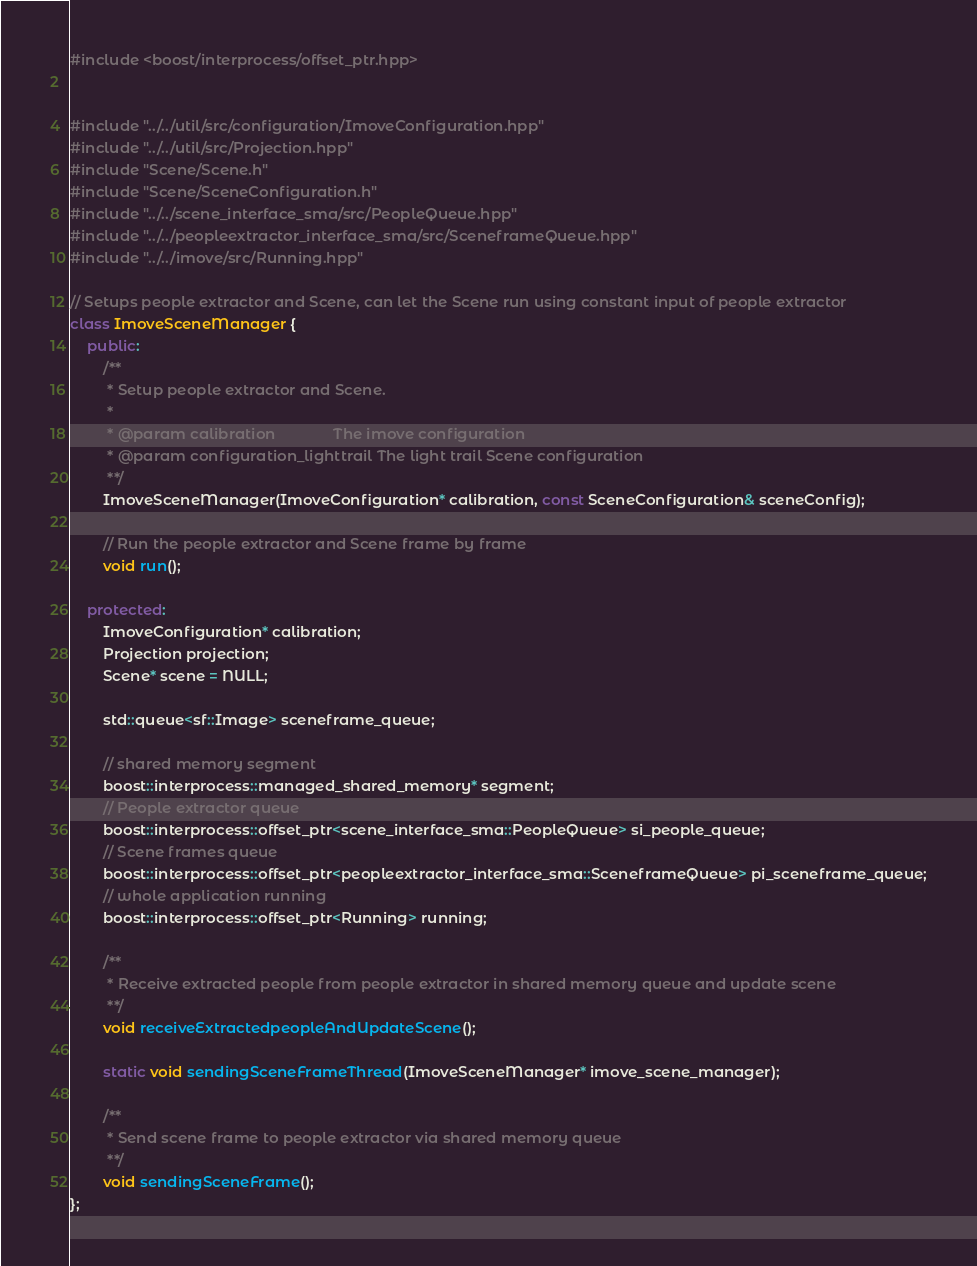Convert code to text. <code><loc_0><loc_0><loc_500><loc_500><_C++_>#include <boost/interprocess/offset_ptr.hpp>


#include "../../util/src/configuration/ImoveConfiguration.hpp"
#include "../../util/src/Projection.hpp"
#include "Scene/Scene.h"
#include "Scene/SceneConfiguration.h"
#include "../../scene_interface_sma/src/PeopleQueue.hpp"
#include "../../peopleextractor_interface_sma/src/SceneframeQueue.hpp"
#include "../../imove/src/Running.hpp"

// Setups people extractor and Scene, can let the Scene run using constant input of people extractor
class ImoveSceneManager {
	public:
		/**
		 * Setup people extractor and Scene.
		 *
		 * @param calibration              The imove configuration
		 * @param configuration_lighttrail The light trail Scene configuration
		 **/
		ImoveSceneManager(ImoveConfiguration* calibration, const SceneConfiguration& sceneConfig);

		// Run the people extractor and Scene frame by frame
		void run();

	protected:
		ImoveConfiguration* calibration;
		Projection projection;
		Scene* scene = NULL;

		std::queue<sf::Image> sceneframe_queue;

		// shared memory segment
		boost::interprocess::managed_shared_memory* segment;
		// People extractor queue
		boost::interprocess::offset_ptr<scene_interface_sma::PeopleQueue> si_people_queue;
		// Scene frames queue
		boost::interprocess::offset_ptr<peopleextractor_interface_sma::SceneframeQueue> pi_sceneframe_queue;
		// whole application running
		boost::interprocess::offset_ptr<Running> running;

		/**
		 * Receive extracted people from people extractor in shared memory queue and update scene
		 **/
		void receiveExtractedpeopleAndUpdateScene();

		static void sendingSceneFrameThread(ImoveSceneManager* imove_scene_manager);

		/**
		 * Send scene frame to people extractor via shared memory queue
		 **/
		void sendingSceneFrame();
};
</code> 